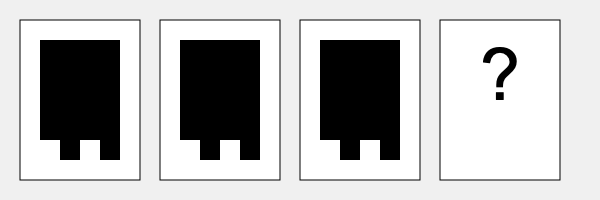Given the 8-bit character animation sequence shown above, what would be the most likely next frame in the sequence? To determine the next frame in the 8-bit character animation sequence, we need to analyze the pattern in the existing frames:

1. The character's body (large black rectangle) remains static across all frames.
2. The character's legs (small black rectangles at the bottom) are moving in a walking animation.
3. The pattern of leg movement is as follows:
   - Frame 1: Left leg forward, right leg back
   - Frame 2: Both legs together (mid-step)
   - Frame 3: Right leg forward, left leg back

4. This suggests a classic 4-frame walking animation cycle, where the 4th frame would return to the initial position to complete the loop.

5. Therefore, the most likely next frame (Frame 4) would be identical to Frame 1, with the left leg forward and the right leg back.

This cycle creates the illusion of continuous walking when the frames are played in sequence, a common technique in 8-bit game development.
Answer: Frame identical to Frame 1 (left leg forward, right leg back) 